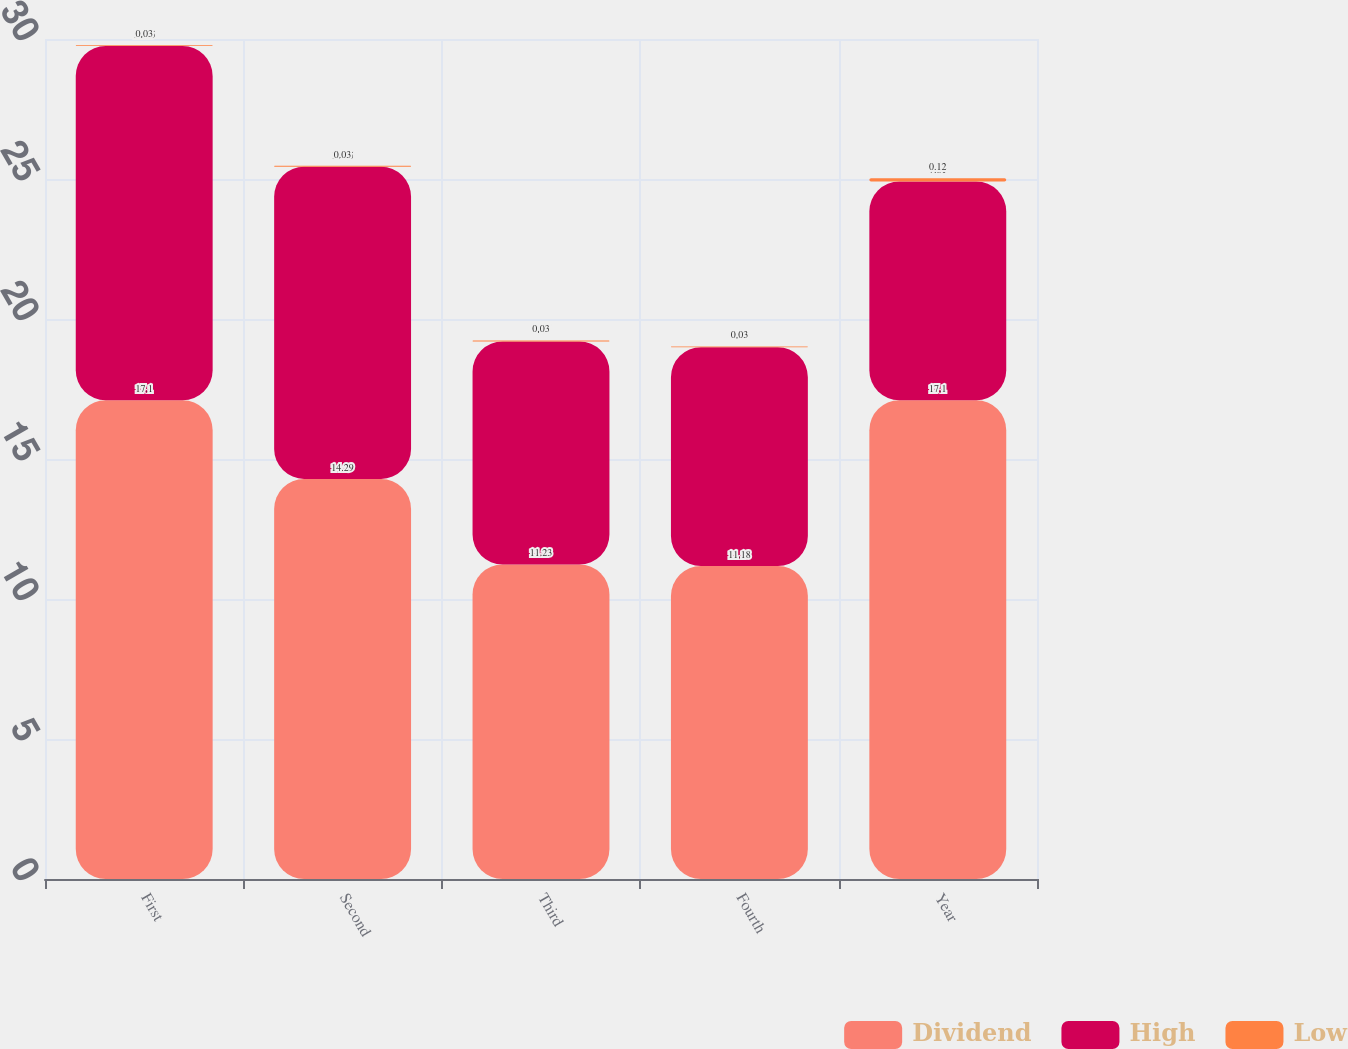Convert chart to OTSL. <chart><loc_0><loc_0><loc_500><loc_500><stacked_bar_chart><ecel><fcel>First<fcel>Second<fcel>Third<fcel>Fourth<fcel>Year<nl><fcel>Dividend<fcel>17.1<fcel>14.29<fcel>11.23<fcel>11.18<fcel>17.1<nl><fcel>High<fcel>12.65<fcel>11.15<fcel>7.97<fcel>7.81<fcel>7.81<nl><fcel>Low<fcel>0.03<fcel>0.03<fcel>0.03<fcel>0.03<fcel>0.12<nl></chart> 